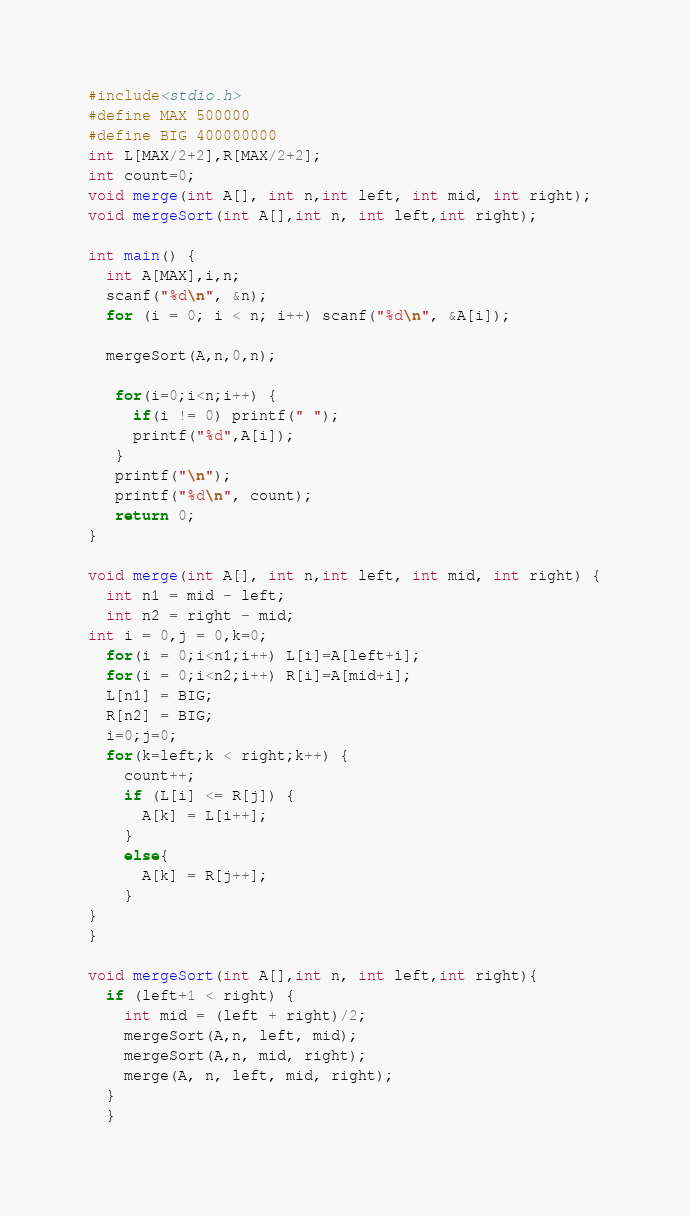Convert code to text. <code><loc_0><loc_0><loc_500><loc_500><_C_>#include<stdio.h>
#define MAX 500000
#define BIG 400000000
int L[MAX/2+2],R[MAX/2+2];
int count=0;
void merge(int A[], int n,int left, int mid, int right);
void mergeSort(int A[],int n, int left,int right);

int main() {
  int A[MAX],i,n;
  scanf("%d\n", &n);
  for (i = 0; i < n; i++) scanf("%d\n", &A[i]);

  mergeSort(A,n,0,n);

   for(i=0;i<n;i++) {
     if(i != 0) printf(" ");
     printf("%d",A[i]);
   }
   printf("\n");
   printf("%d\n", count);
   return 0;
}

void merge(int A[], int n,int left, int mid, int right) {
  int n1 = mid - left;
  int n2 = right - mid;
int i = 0,j = 0,k=0;
  for(i = 0;i<n1;i++) L[i]=A[left+i];
  for(i = 0;i<n2;i++) R[i]=A[mid+i];
  L[n1] = BIG;
  R[n2] = BIG;
  i=0;j=0;
  for(k=left;k < right;k++) {
    count++;
    if (L[i] <= R[j]) {
      A[k] = L[i++];
    }
    else{
      A[k] = R[j++];
    }
}
}

void mergeSort(int A[],int n, int left,int right){
  if (left+1 < right) {
    int mid = (left + right)/2;
    mergeSort(A,n, left, mid);
    mergeSort(A,n, mid, right);
    merge(A, n, left, mid, right);
  }
  }</code> 